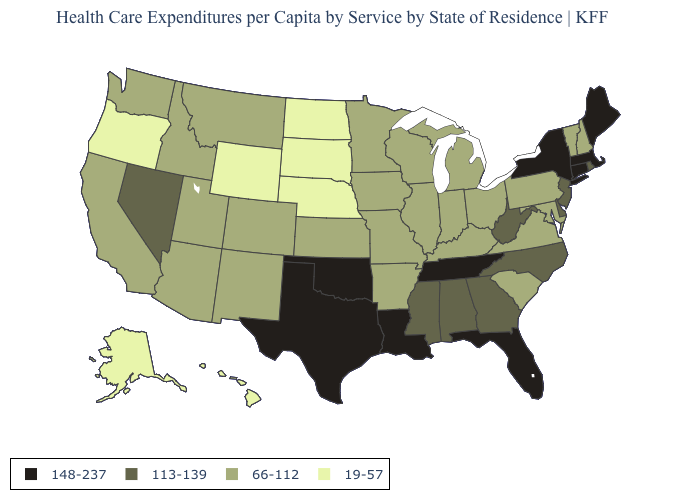Does Michigan have the lowest value in the USA?
Write a very short answer. No. Does California have a lower value than Florida?
Answer briefly. Yes. What is the value of Missouri?
Be succinct. 66-112. What is the lowest value in the USA?
Keep it brief. 19-57. Does South Dakota have the highest value in the USA?
Answer briefly. No. Does Hawaii have a lower value than Washington?
Answer briefly. Yes. Among the states that border New York , which have the highest value?
Be succinct. Connecticut, Massachusetts. Name the states that have a value in the range 113-139?
Be succinct. Alabama, Delaware, Georgia, Mississippi, Nevada, New Jersey, North Carolina, Rhode Island, West Virginia. Name the states that have a value in the range 66-112?
Be succinct. Arizona, Arkansas, California, Colorado, Idaho, Illinois, Indiana, Iowa, Kansas, Kentucky, Maryland, Michigan, Minnesota, Missouri, Montana, New Hampshire, New Mexico, Ohio, Pennsylvania, South Carolina, Utah, Vermont, Virginia, Washington, Wisconsin. What is the value of Michigan?
Be succinct. 66-112. What is the lowest value in the MidWest?
Give a very brief answer. 19-57. Does Iowa have a lower value than Louisiana?
Keep it brief. Yes. Is the legend a continuous bar?
Short answer required. No. Does New York have the highest value in the USA?
Quick response, please. Yes. Among the states that border Arkansas , which have the highest value?
Concise answer only. Louisiana, Oklahoma, Tennessee, Texas. 